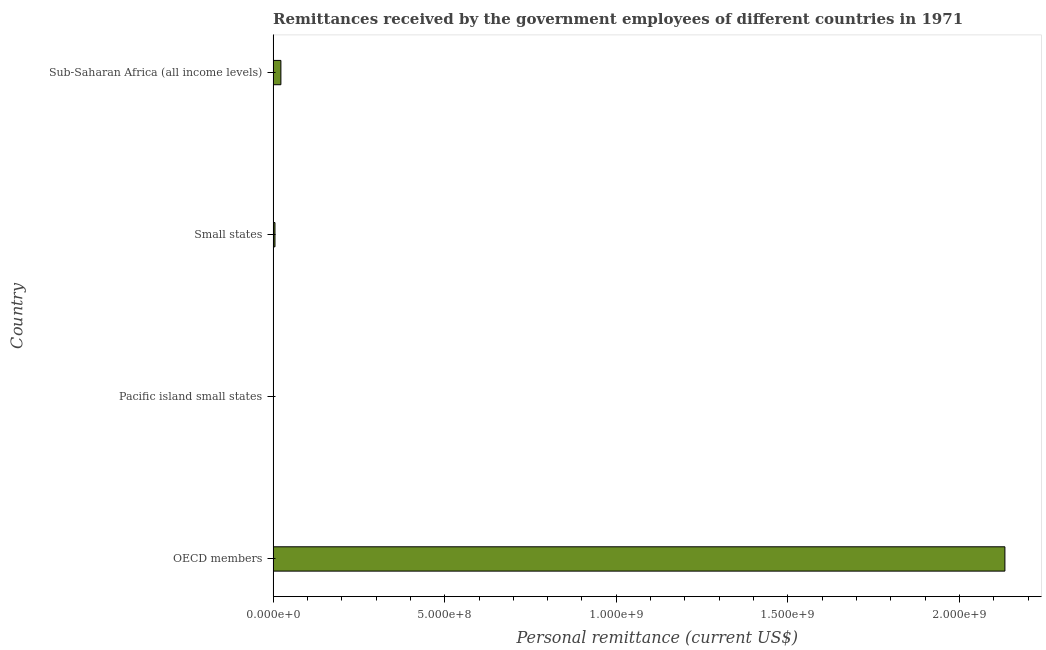Does the graph contain any zero values?
Keep it short and to the point. No. Does the graph contain grids?
Provide a short and direct response. No. What is the title of the graph?
Provide a short and direct response. Remittances received by the government employees of different countries in 1971. What is the label or title of the X-axis?
Ensure brevity in your answer.  Personal remittance (current US$). What is the personal remittances in OECD members?
Your answer should be compact. 2.13e+09. Across all countries, what is the maximum personal remittances?
Ensure brevity in your answer.  2.13e+09. Across all countries, what is the minimum personal remittances?
Give a very brief answer. 7.94e+05. In which country was the personal remittances minimum?
Provide a succinct answer. Pacific island small states. What is the sum of the personal remittances?
Ensure brevity in your answer.  2.16e+09. What is the difference between the personal remittances in OECD members and Pacific island small states?
Keep it short and to the point. 2.13e+09. What is the average personal remittances per country?
Ensure brevity in your answer.  5.40e+08. What is the median personal remittances?
Your answer should be compact. 1.40e+07. In how many countries, is the personal remittances greater than 900000000 US$?
Your answer should be compact. 1. What is the ratio of the personal remittances in Pacific island small states to that in Small states?
Keep it short and to the point. 0.15. Is the personal remittances in Pacific island small states less than that in Sub-Saharan Africa (all income levels)?
Ensure brevity in your answer.  Yes. What is the difference between the highest and the second highest personal remittances?
Keep it short and to the point. 2.11e+09. Is the sum of the personal remittances in Small states and Sub-Saharan Africa (all income levels) greater than the maximum personal remittances across all countries?
Provide a short and direct response. No. What is the difference between the highest and the lowest personal remittances?
Ensure brevity in your answer.  2.13e+09. In how many countries, is the personal remittances greater than the average personal remittances taken over all countries?
Give a very brief answer. 1. How many countries are there in the graph?
Your response must be concise. 4. What is the Personal remittance (current US$) of OECD members?
Offer a very short reply. 2.13e+09. What is the Personal remittance (current US$) of Pacific island small states?
Your answer should be compact. 7.94e+05. What is the Personal remittance (current US$) of Small states?
Your response must be concise. 5.40e+06. What is the Personal remittance (current US$) in Sub-Saharan Africa (all income levels)?
Your response must be concise. 2.26e+07. What is the difference between the Personal remittance (current US$) in OECD members and Pacific island small states?
Your response must be concise. 2.13e+09. What is the difference between the Personal remittance (current US$) in OECD members and Small states?
Give a very brief answer. 2.13e+09. What is the difference between the Personal remittance (current US$) in OECD members and Sub-Saharan Africa (all income levels)?
Provide a short and direct response. 2.11e+09. What is the difference between the Personal remittance (current US$) in Pacific island small states and Small states?
Make the answer very short. -4.61e+06. What is the difference between the Personal remittance (current US$) in Pacific island small states and Sub-Saharan Africa (all income levels)?
Your response must be concise. -2.18e+07. What is the difference between the Personal remittance (current US$) in Small states and Sub-Saharan Africa (all income levels)?
Your answer should be compact. -1.72e+07. What is the ratio of the Personal remittance (current US$) in OECD members to that in Pacific island small states?
Make the answer very short. 2686.65. What is the ratio of the Personal remittance (current US$) in OECD members to that in Small states?
Keep it short and to the point. 394.8. What is the ratio of the Personal remittance (current US$) in OECD members to that in Sub-Saharan Africa (all income levels)?
Your answer should be very brief. 94.2. What is the ratio of the Personal remittance (current US$) in Pacific island small states to that in Small states?
Make the answer very short. 0.15. What is the ratio of the Personal remittance (current US$) in Pacific island small states to that in Sub-Saharan Africa (all income levels)?
Ensure brevity in your answer.  0.04. What is the ratio of the Personal remittance (current US$) in Small states to that in Sub-Saharan Africa (all income levels)?
Offer a terse response. 0.24. 